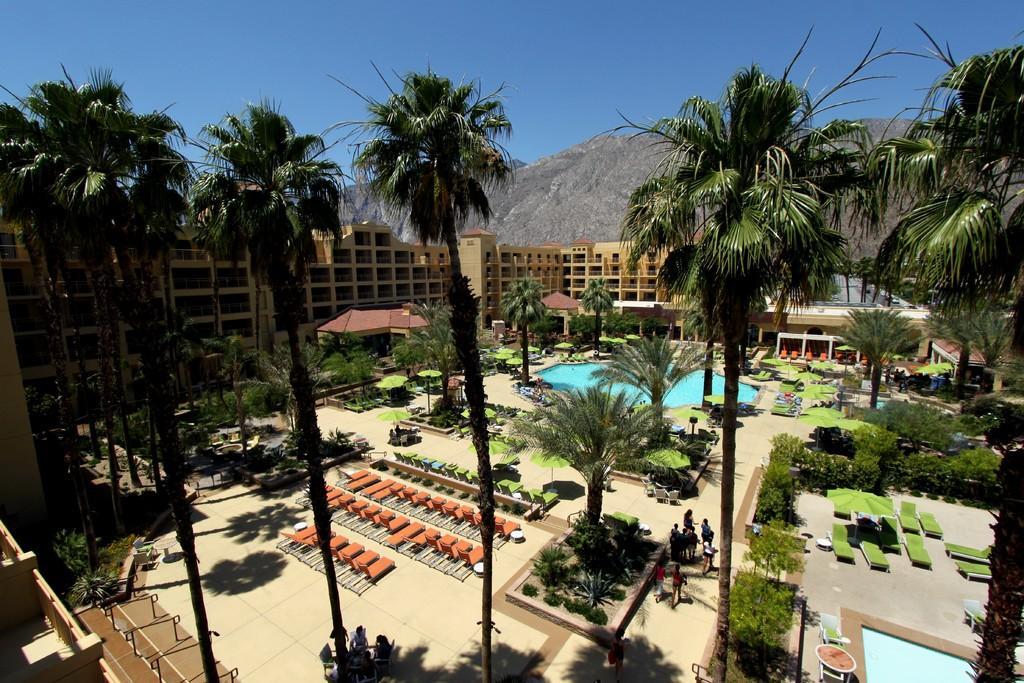How would you summarize this image in a sentence or two? In this image there are a few people sitting on the chairs and there are a few people walking. There are beds, tents, plants, trees, buildings, swimming pools. In the background of the image there are mountains. At the top of the image there is sky. 